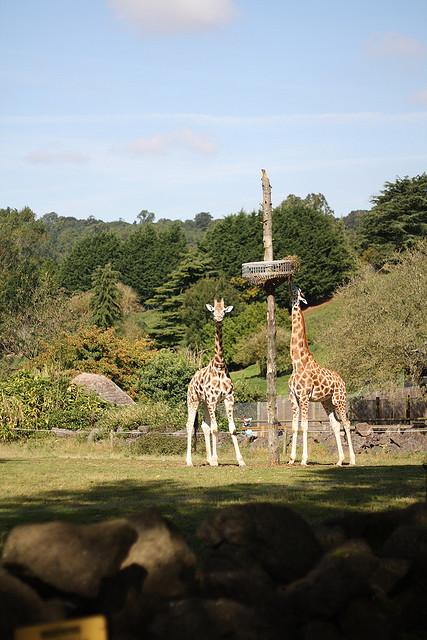How many animals are pictured?
Keep it brief. 2. Are the animals eating?
Be succinct. Yes. Is this a controlled environment?
Answer briefly. Yes. 